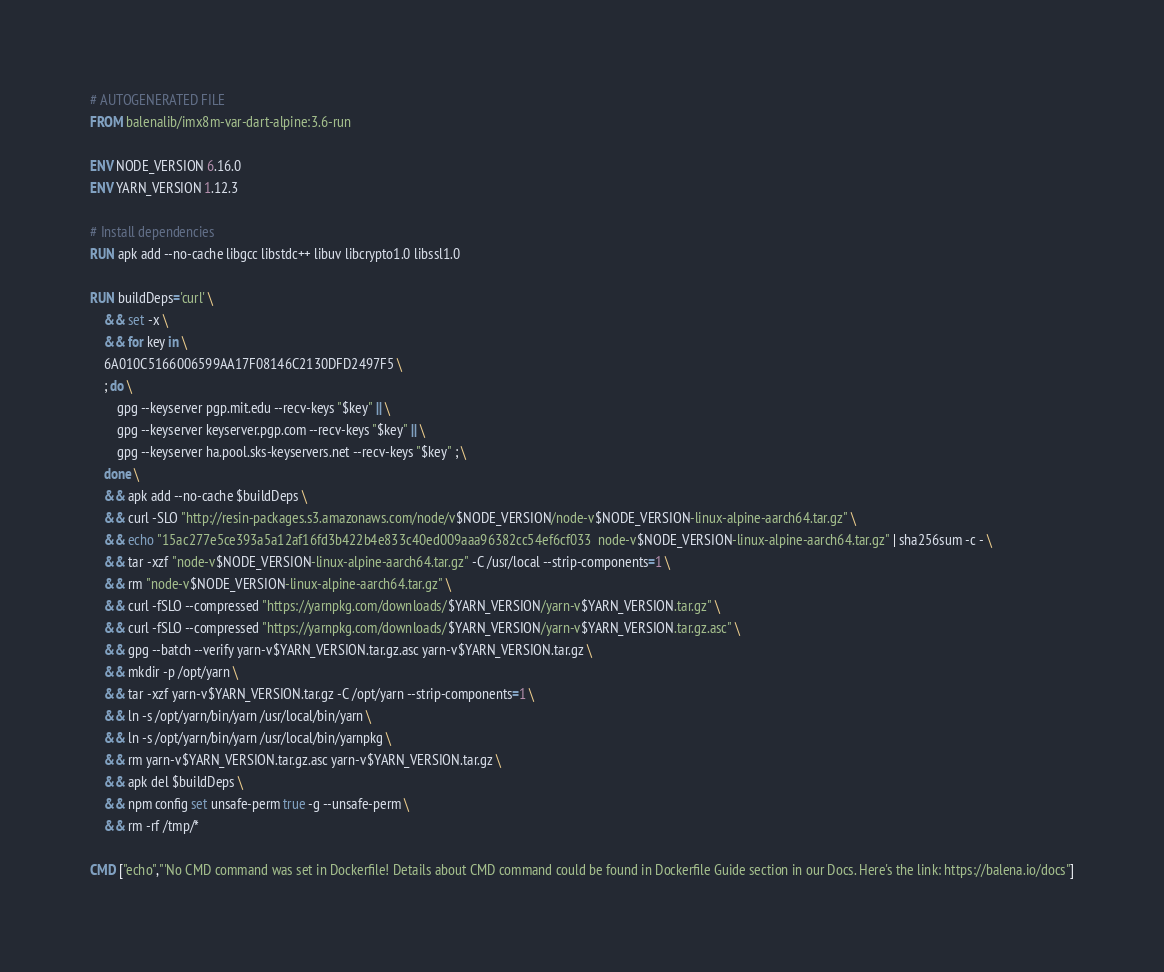<code> <loc_0><loc_0><loc_500><loc_500><_Dockerfile_># AUTOGENERATED FILE
FROM balenalib/imx8m-var-dart-alpine:3.6-run

ENV NODE_VERSION 6.16.0
ENV YARN_VERSION 1.12.3

# Install dependencies
RUN apk add --no-cache libgcc libstdc++ libuv libcrypto1.0 libssl1.0

RUN buildDeps='curl' \
	&& set -x \
	&& for key in \
	6A010C5166006599AA17F08146C2130DFD2497F5 \
	; do \
		gpg --keyserver pgp.mit.edu --recv-keys "$key" || \
		gpg --keyserver keyserver.pgp.com --recv-keys "$key" || \
		gpg --keyserver ha.pool.sks-keyservers.net --recv-keys "$key" ; \
	done \
	&& apk add --no-cache $buildDeps \
	&& curl -SLO "http://resin-packages.s3.amazonaws.com/node/v$NODE_VERSION/node-v$NODE_VERSION-linux-alpine-aarch64.tar.gz" \
	&& echo "15ac277e5ce393a5a12af16fd3b422b4e833c40ed009aaa96382cc54ef6cf033  node-v$NODE_VERSION-linux-alpine-aarch64.tar.gz" | sha256sum -c - \
	&& tar -xzf "node-v$NODE_VERSION-linux-alpine-aarch64.tar.gz" -C /usr/local --strip-components=1 \
	&& rm "node-v$NODE_VERSION-linux-alpine-aarch64.tar.gz" \
	&& curl -fSLO --compressed "https://yarnpkg.com/downloads/$YARN_VERSION/yarn-v$YARN_VERSION.tar.gz" \
	&& curl -fSLO --compressed "https://yarnpkg.com/downloads/$YARN_VERSION/yarn-v$YARN_VERSION.tar.gz.asc" \
	&& gpg --batch --verify yarn-v$YARN_VERSION.tar.gz.asc yarn-v$YARN_VERSION.tar.gz \
	&& mkdir -p /opt/yarn \
	&& tar -xzf yarn-v$YARN_VERSION.tar.gz -C /opt/yarn --strip-components=1 \
	&& ln -s /opt/yarn/bin/yarn /usr/local/bin/yarn \
	&& ln -s /opt/yarn/bin/yarn /usr/local/bin/yarnpkg \
	&& rm yarn-v$YARN_VERSION.tar.gz.asc yarn-v$YARN_VERSION.tar.gz \
	&& apk del $buildDeps \
	&& npm config set unsafe-perm true -g --unsafe-perm \
	&& rm -rf /tmp/*

CMD ["echo","'No CMD command was set in Dockerfile! Details about CMD command could be found in Dockerfile Guide section in our Docs. Here's the link: https://balena.io/docs"]</code> 